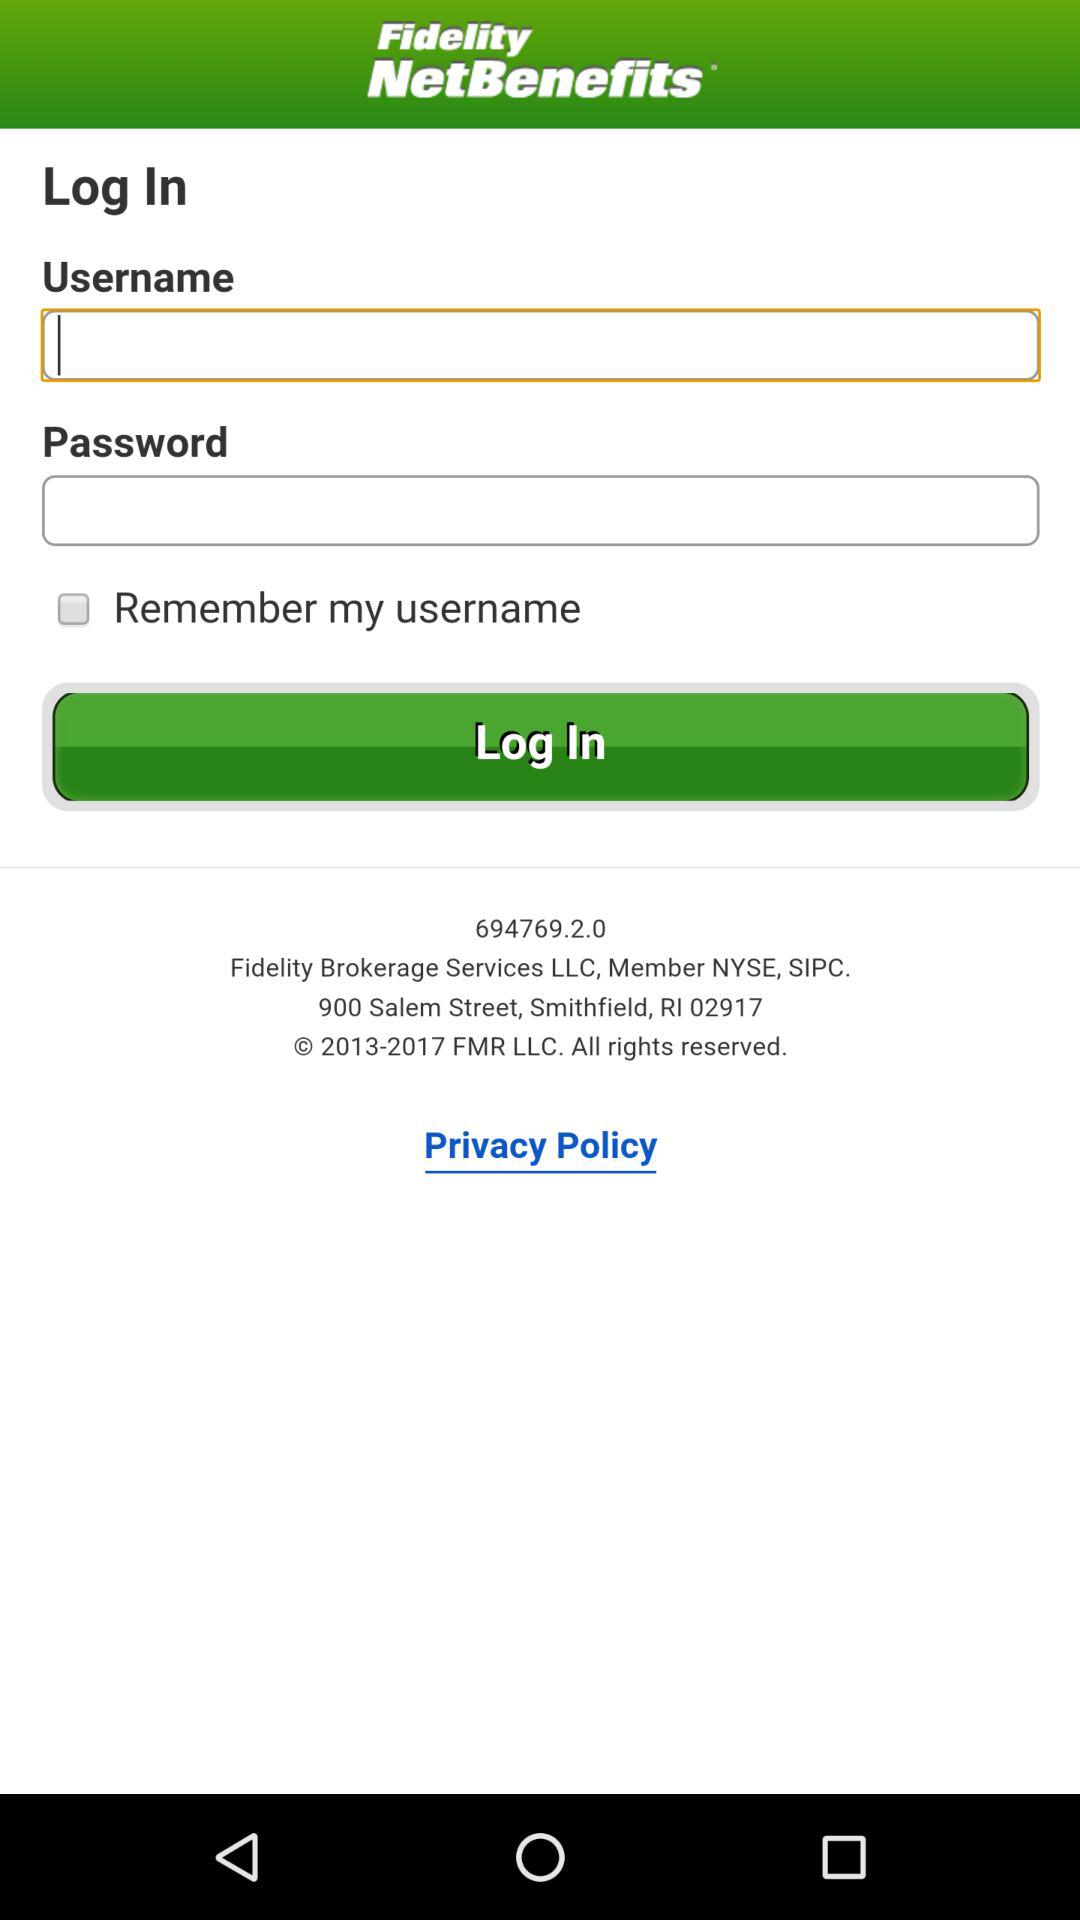What is the name of the application? The name of the application is "Fidelity NetBenefits". 